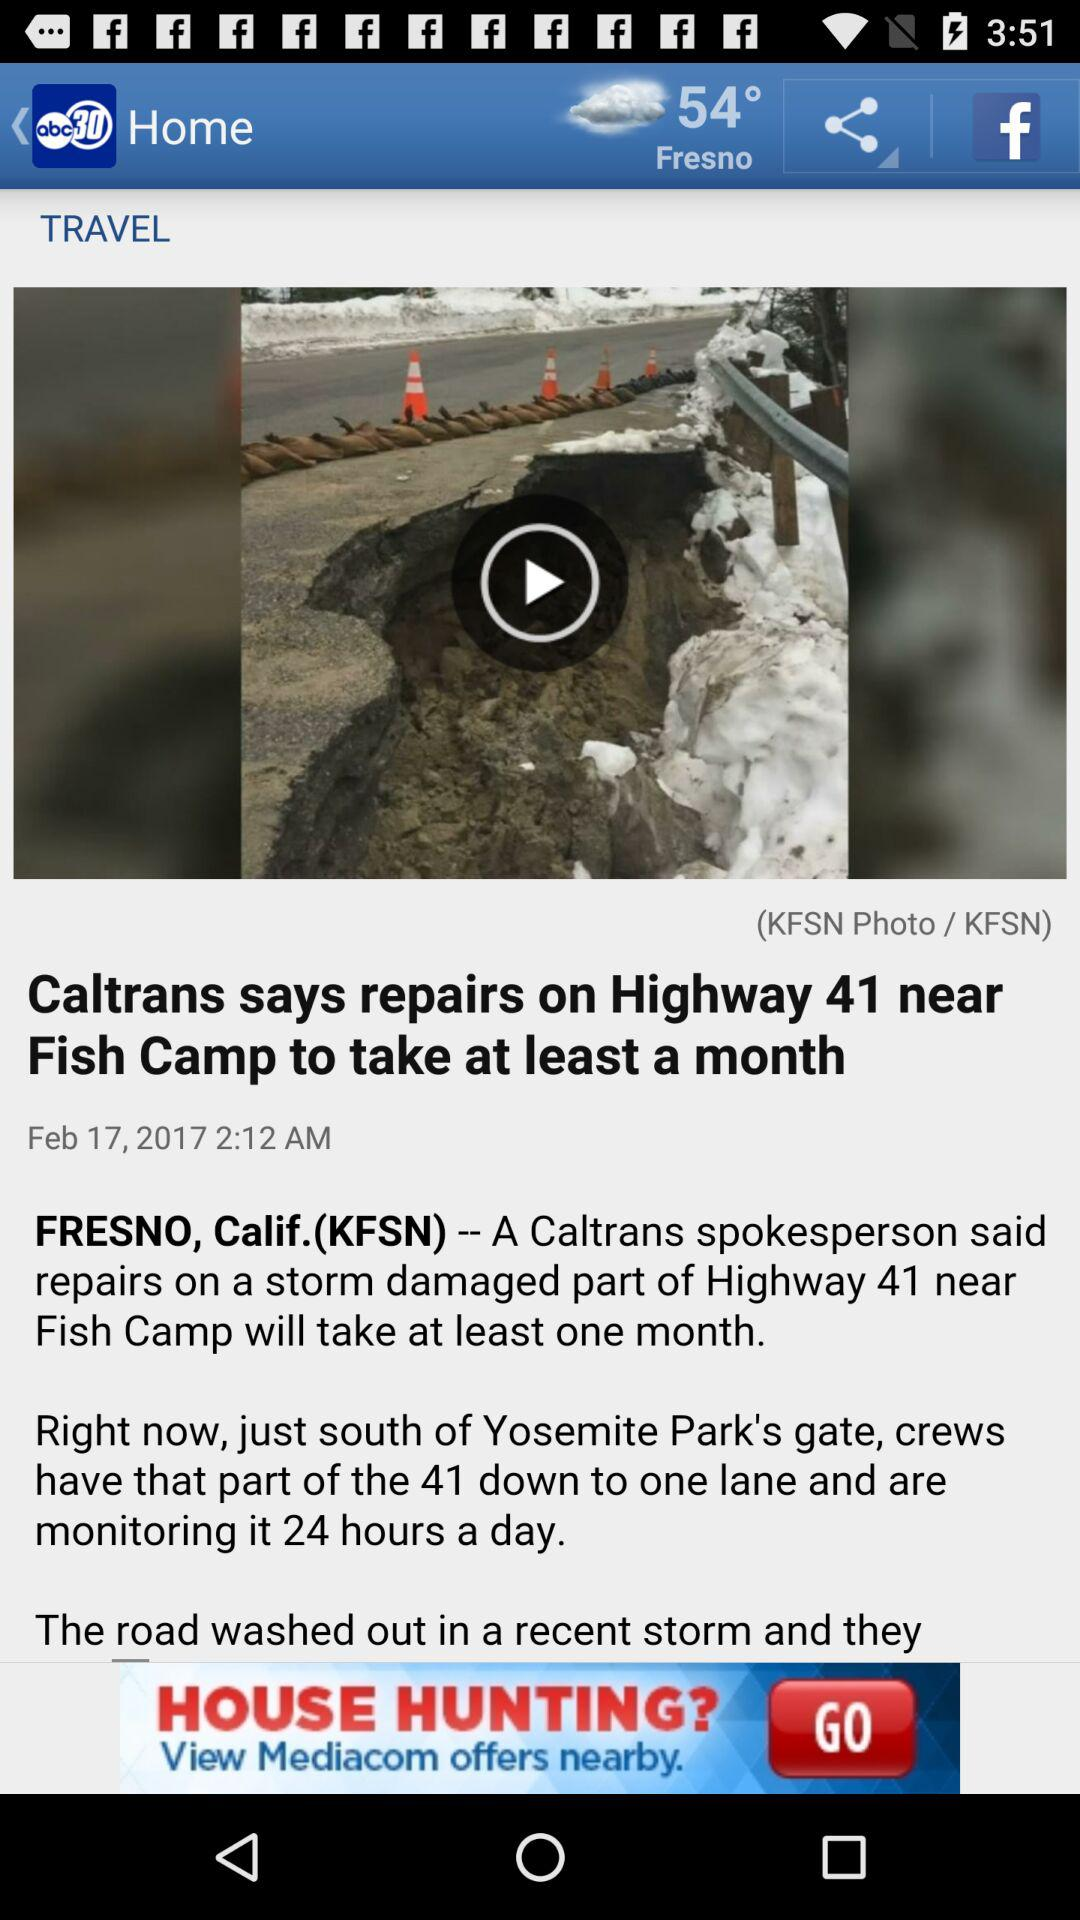What is the weather like in Fresno? The weather in Fresno is cloudy. 